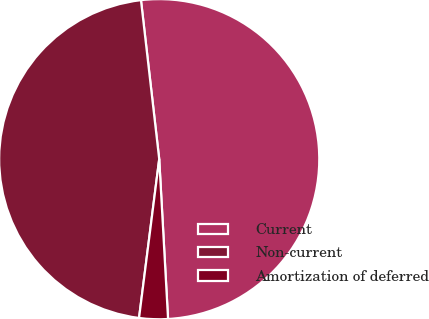<chart> <loc_0><loc_0><loc_500><loc_500><pie_chart><fcel>Current<fcel>Non-current<fcel>Amortization of deferred<nl><fcel>50.94%<fcel>46.17%<fcel>2.89%<nl></chart> 